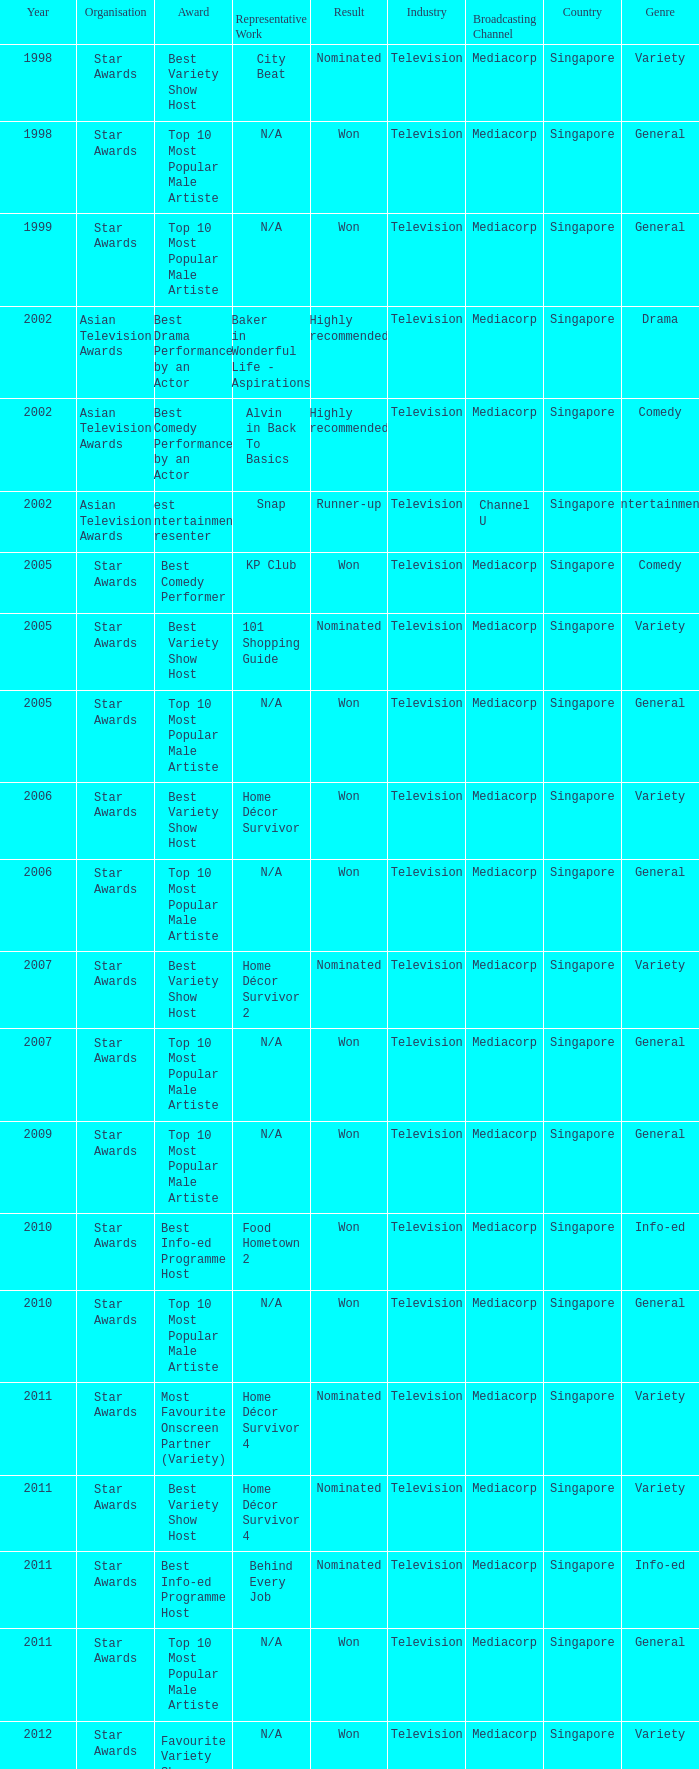What is the award for the Star Awards earlier than 2005 and the result is won? Top 10 Most Popular Male Artiste, Top 10 Most Popular Male Artiste. 